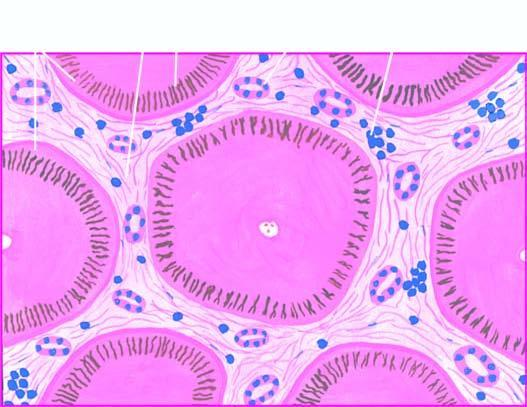what are fibrous scars dividing the hepatic parenchyma into?
Answer the question using a single word or phrase. Micronodules 